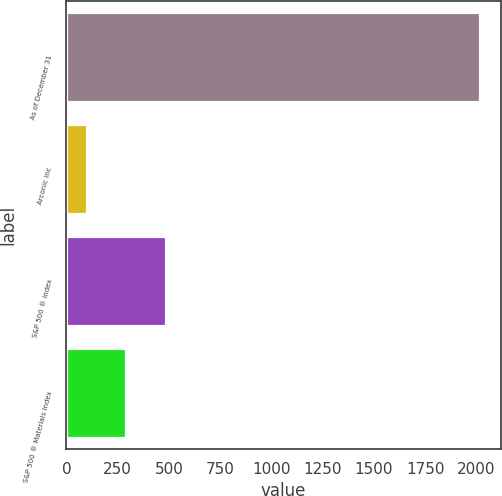Convert chart to OTSL. <chart><loc_0><loc_0><loc_500><loc_500><bar_chart><fcel>As of December 31<fcel>Arconic Inc<fcel>S&P 500 ® Index<fcel>S&P 500 ® Materials Index<nl><fcel>2016<fcel>101<fcel>484<fcel>292.5<nl></chart> 